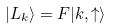<formula> <loc_0><loc_0><loc_500><loc_500>| L _ { k } \rangle = F | k , \uparrow \rangle</formula> 